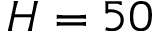Convert formula to latex. <formula><loc_0><loc_0><loc_500><loc_500>H = 5 0</formula> 